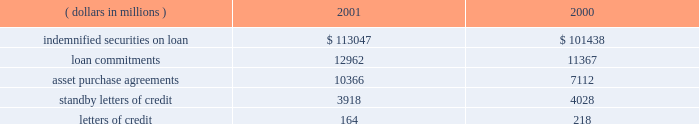Loan commitments ( unfunded loans and unused lines of credit ) , asset purchase agreements , standby letters of credit and letters of credit are issued to accommodate the financing needs of state street 2019s clients and to provide credit enhancements to special purpose entities .
Loan commitments are agreements by state street to lend monies at a future date .
Asset purchase agreements are commitments to purchase receivables or securities , subject to conditions established in the agreements , and at december 31 , 2001 , include $ 8.0 billion outstanding to special purpose entities .
Standby letters of credit and letters of credit commit state street to make payments on behalf of clients and special purpose entities when certain specified events occur .
Standby letters of credit outstanding to special purpose entities were $ 608 million at december 31 , 2001 .
These loan , asset purchase and letter of credit commitments are subject to the same credit policies and reviews as loans .
The amount and nature of collateral are obtained based upon management 2019s assessment of the credit risk .
Approximately 89% ( 89 % ) of the loan commitments and asset purchase agreements expire within one year from the date of issue .
Sincemany of the commitments are expected to expire or renewwithout being drawn , the total commitment amounts do not necessarily represent future cash requirements .
The following is a summary of the contractual amount of credit-related , off-balance sheet financial instruments at december 31: .
State street corporation 53 .
What is the percentage change in the balance of loan commitments from 2000 to 2001? 
Computations: ((12962 - 11367) / 11367)
Answer: 0.14032. 